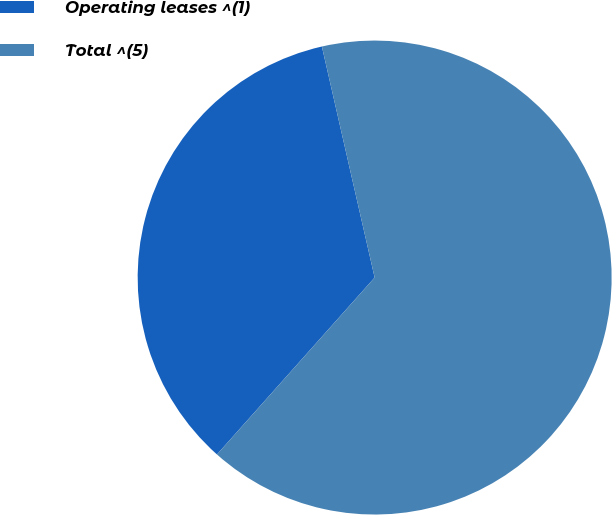Convert chart to OTSL. <chart><loc_0><loc_0><loc_500><loc_500><pie_chart><fcel>Operating leases ^(1)<fcel>Total ^(5)<nl><fcel>34.84%<fcel>65.16%<nl></chart> 